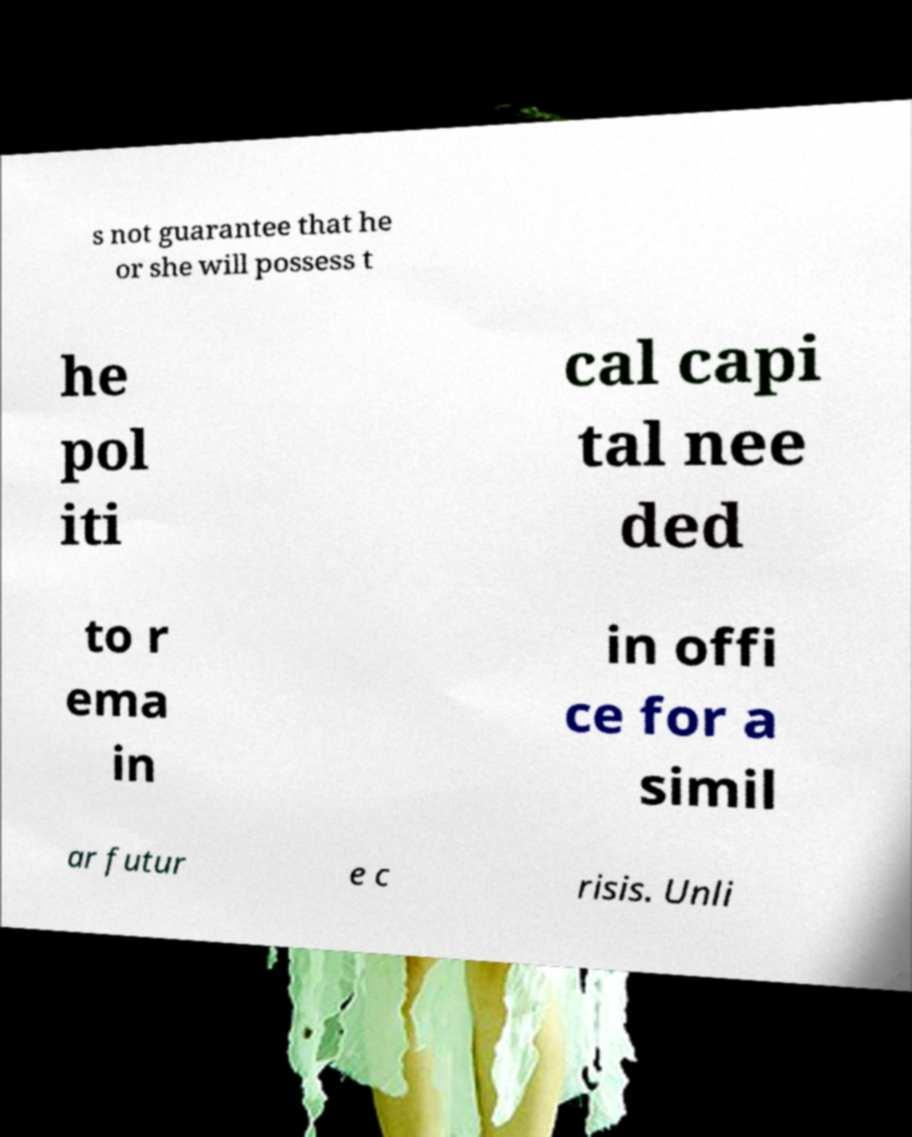Can you accurately transcribe the text from the provided image for me? s not guarantee that he or she will possess t he pol iti cal capi tal nee ded to r ema in in offi ce for a simil ar futur e c risis. Unli 